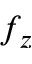<formula> <loc_0><loc_0><loc_500><loc_500>f _ { z }</formula> 